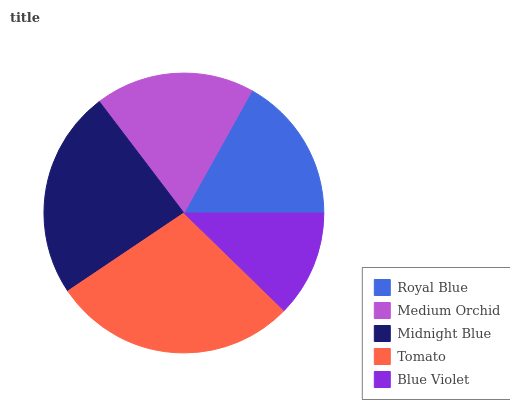Is Blue Violet the minimum?
Answer yes or no. Yes. Is Tomato the maximum?
Answer yes or no. Yes. Is Medium Orchid the minimum?
Answer yes or no. No. Is Medium Orchid the maximum?
Answer yes or no. No. Is Medium Orchid greater than Royal Blue?
Answer yes or no. Yes. Is Royal Blue less than Medium Orchid?
Answer yes or no. Yes. Is Royal Blue greater than Medium Orchid?
Answer yes or no. No. Is Medium Orchid less than Royal Blue?
Answer yes or no. No. Is Medium Orchid the high median?
Answer yes or no. Yes. Is Medium Orchid the low median?
Answer yes or no. Yes. Is Royal Blue the high median?
Answer yes or no. No. Is Blue Violet the low median?
Answer yes or no. No. 